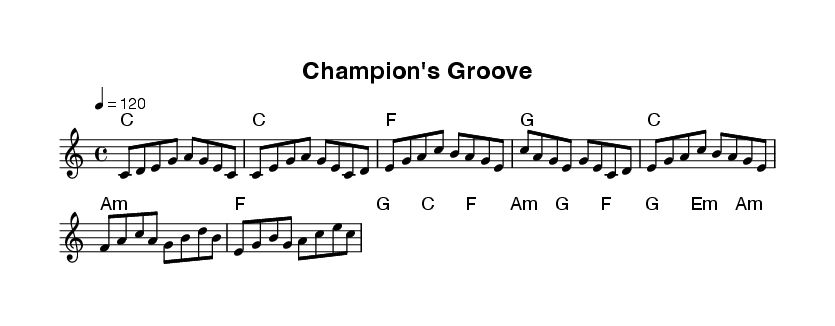What is the key signature of this music? The key signature is indicated in the global section of the sheet music, where it shows " \key c \major," meaning there are no sharps or flats.
Answer: C major What is the time signature of this music? The time signature appears in the global section where it states "\time 4/4," indicating that there are four beats per measure and the quarter note gets one beat.
Answer: 4/4 What is the tempo marking for this piece? The tempo is given in the global section as "\tempo 4 = 120," which indicates the speed of the music, specifying 120 beats per minute.
Answer: 120 How many sections are in the piece? The piece is structured into four sections: Intro, Verse, Chorus, and Bridge, all outlined in the melody. By counting these distinct sections in the score, we find there are four.
Answer: Four What is the theme of the lyrics in the chorus? The lyrics in the chorus focus on celebration and victory, with phrases emphasizing being champions and the joy of triumph. This theme is evident from the content of the provided lyrics in the chorus section.
Answer: Celebration How does the bridge relate to the other sections? The bridge introduces new chords and melody elements not present in the verse or chorus, providing a contrast that enhances the overall structure. It draws on different harmonies and transitions back smoothly to the chorus, which can be inferred from analyzing its unique setup compared to the other sections.
Answer: Contrast 